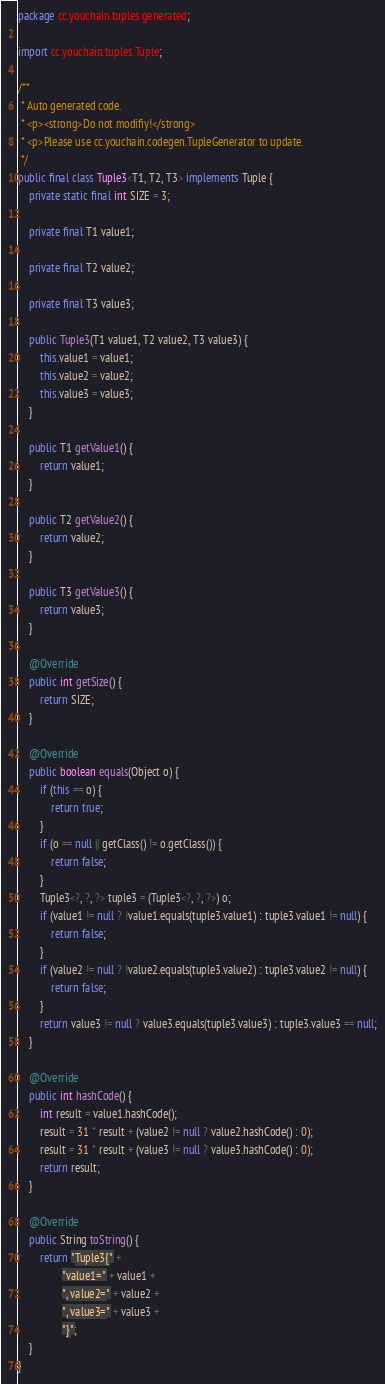Convert code to text. <code><loc_0><loc_0><loc_500><loc_500><_Java_>package cc.youchain.tuples.generated;

import cc.youchain.tuples.Tuple;

/**
 * Auto generated code.
 * <p><strong>Do not modifiy!</strong>
 * <p>Please use cc.youchain.codegen.TupleGenerator to update.
 */
public final class Tuple3<T1, T2, T3> implements Tuple {
    private static final int SIZE = 3;

    private final T1 value1;

    private final T2 value2;

    private final T3 value3;

    public Tuple3(T1 value1, T2 value2, T3 value3) {
        this.value1 = value1;
        this.value2 = value2;
        this.value3 = value3;
    }

    public T1 getValue1() {
        return value1;
    }

    public T2 getValue2() {
        return value2;
    }

    public T3 getValue3() {
        return value3;
    }

    @Override
    public int getSize() {
        return SIZE;
    }

    @Override
    public boolean equals(Object o) {
        if (this == o) {
            return true;
        }
        if (o == null || getClass() != o.getClass()) {
            return false;
        }
        Tuple3<?, ?, ?> tuple3 = (Tuple3<?, ?, ?>) o;
        if (value1 != null ? !value1.equals(tuple3.value1) : tuple3.value1 != null) {
            return false;
        }
        if (value2 != null ? !value2.equals(tuple3.value2) : tuple3.value2 != null) {
            return false;
        }
        return value3 != null ? value3.equals(tuple3.value3) : tuple3.value3 == null;
    }

    @Override
    public int hashCode() {
        int result = value1.hashCode();
        result = 31 * result + (value2 != null ? value2.hashCode() : 0);
        result = 31 * result + (value3 != null ? value3.hashCode() : 0);
        return result;
    }

    @Override
    public String toString() {
        return "Tuple3{" +
                "value1=" + value1 +
                ", value2=" + value2 +
                ", value3=" + value3 +
                "}";
    }
}
</code> 